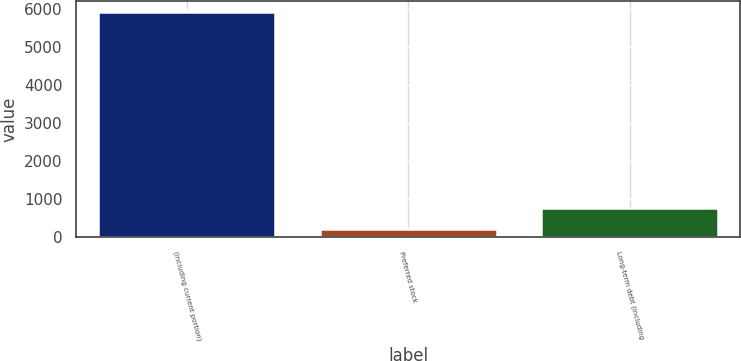<chart> <loc_0><loc_0><loc_500><loc_500><bar_chart><fcel>(including current portion)<fcel>Preferred stock<fcel>Long-term debt (including<nl><fcel>5912<fcel>211<fcel>781.1<nl></chart> 